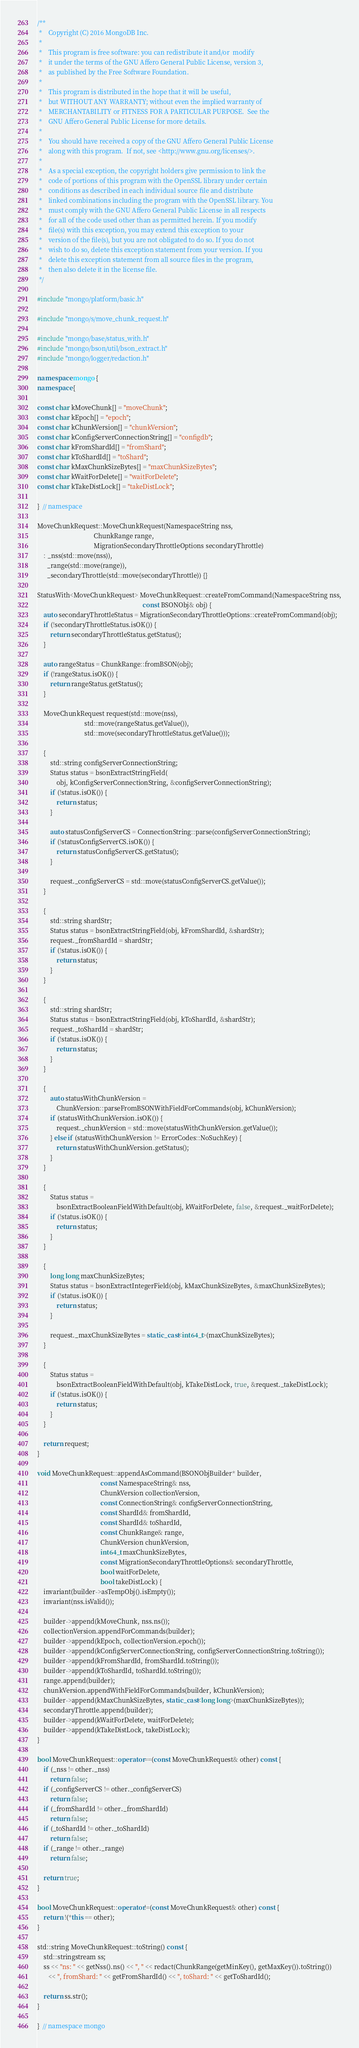<code> <loc_0><loc_0><loc_500><loc_500><_C++_>/**
 *    Copyright (C) 2016 MongoDB Inc.
 *
 *    This program is free software: you can redistribute it and/or  modify
 *    it under the terms of the GNU Affero General Public License, version 3,
 *    as published by the Free Software Foundation.
 *
 *    This program is distributed in the hope that it will be useful,
 *    but WITHOUT ANY WARRANTY; without even the implied warranty of
 *    MERCHANTABILITY or FITNESS FOR A PARTICULAR PURPOSE.  See the
 *    GNU Affero General Public License for more details.
 *
 *    You should have received a copy of the GNU Affero General Public License
 *    along with this program.  If not, see <http://www.gnu.org/licenses/>.
 *
 *    As a special exception, the copyright holders give permission to link the
 *    code of portions of this program with the OpenSSL library under certain
 *    conditions as described in each individual source file and distribute
 *    linked combinations including the program with the OpenSSL library. You
 *    must comply with the GNU Affero General Public License in all respects
 *    for all of the code used other than as permitted herein. If you modify
 *    file(s) with this exception, you may extend this exception to your
 *    version of the file(s), but you are not obligated to do so. If you do not
 *    wish to do so, delete this exception statement from your version. If you
 *    delete this exception statement from all source files in the program,
 *    then also delete it in the license file.
 */

#include "mongo/platform/basic.h"

#include "mongo/s/move_chunk_request.h"

#include "mongo/base/status_with.h"
#include "mongo/bson/util/bson_extract.h"
#include "mongo/logger/redaction.h"

namespace mongo {
namespace {

const char kMoveChunk[] = "moveChunk";
const char kEpoch[] = "epoch";
const char kChunkVersion[] = "chunkVersion";
const char kConfigServerConnectionString[] = "configdb";
const char kFromShardId[] = "fromShard";
const char kToShardId[] = "toShard";
const char kMaxChunkSizeBytes[] = "maxChunkSizeBytes";
const char kWaitForDelete[] = "waitForDelete";
const char kTakeDistLock[] = "takeDistLock";

}  // namespace

MoveChunkRequest::MoveChunkRequest(NamespaceString nss,
                                   ChunkRange range,
                                   MigrationSecondaryThrottleOptions secondaryThrottle)
    : _nss(std::move(nss)),
      _range(std::move(range)),
      _secondaryThrottle(std::move(secondaryThrottle)) {}

StatusWith<MoveChunkRequest> MoveChunkRequest::createFromCommand(NamespaceString nss,
                                                                 const BSONObj& obj) {
    auto secondaryThrottleStatus = MigrationSecondaryThrottleOptions::createFromCommand(obj);
    if (!secondaryThrottleStatus.isOK()) {
        return secondaryThrottleStatus.getStatus();
    }

    auto rangeStatus = ChunkRange::fromBSON(obj);
    if (!rangeStatus.isOK()) {
        return rangeStatus.getStatus();
    }

    MoveChunkRequest request(std::move(nss),
                             std::move(rangeStatus.getValue()),
                             std::move(secondaryThrottleStatus.getValue()));

    {
        std::string configServerConnectionString;
        Status status = bsonExtractStringField(
            obj, kConfigServerConnectionString, &configServerConnectionString);
        if (!status.isOK()) {
            return status;
        }

        auto statusConfigServerCS = ConnectionString::parse(configServerConnectionString);
        if (!statusConfigServerCS.isOK()) {
            return statusConfigServerCS.getStatus();
        }

        request._configServerCS = std::move(statusConfigServerCS.getValue());
    }

    {
        std::string shardStr;
        Status status = bsonExtractStringField(obj, kFromShardId, &shardStr);
        request._fromShardId = shardStr;
        if (!status.isOK()) {
            return status;
        }
    }

    {
        std::string shardStr;
        Status status = bsonExtractStringField(obj, kToShardId, &shardStr);
        request._toShardId = shardStr;
        if (!status.isOK()) {
            return status;
        }
    }

    {
        auto statusWithChunkVersion =
            ChunkVersion::parseFromBSONWithFieldForCommands(obj, kChunkVersion);
        if (statusWithChunkVersion.isOK()) {
            request._chunkVersion = std::move(statusWithChunkVersion.getValue());
        } else if (statusWithChunkVersion != ErrorCodes::NoSuchKey) {
            return statusWithChunkVersion.getStatus();
        }
    }

    {
        Status status =
            bsonExtractBooleanFieldWithDefault(obj, kWaitForDelete, false, &request._waitForDelete);
        if (!status.isOK()) {
            return status;
        }
    }

    {
        long long maxChunkSizeBytes;
        Status status = bsonExtractIntegerField(obj, kMaxChunkSizeBytes, &maxChunkSizeBytes);
        if (!status.isOK()) {
            return status;
        }

        request._maxChunkSizeBytes = static_cast<int64_t>(maxChunkSizeBytes);
    }

    {
        Status status =
            bsonExtractBooleanFieldWithDefault(obj, kTakeDistLock, true, &request._takeDistLock);
        if (!status.isOK()) {
            return status;
        }
    }

    return request;
}

void MoveChunkRequest::appendAsCommand(BSONObjBuilder* builder,
                                       const NamespaceString& nss,
                                       ChunkVersion collectionVersion,
                                       const ConnectionString& configServerConnectionString,
                                       const ShardId& fromShardId,
                                       const ShardId& toShardId,
                                       const ChunkRange& range,
                                       ChunkVersion chunkVersion,
                                       int64_t maxChunkSizeBytes,
                                       const MigrationSecondaryThrottleOptions& secondaryThrottle,
                                       bool waitForDelete,
                                       bool takeDistLock) {
    invariant(builder->asTempObj().isEmpty());
    invariant(nss.isValid());

    builder->append(kMoveChunk, nss.ns());
    collectionVersion.appendForCommands(builder);
    builder->append(kEpoch, collectionVersion.epoch());
    builder->append(kConfigServerConnectionString, configServerConnectionString.toString());
    builder->append(kFromShardId, fromShardId.toString());
    builder->append(kToShardId, toShardId.toString());
    range.append(builder);
    chunkVersion.appendWithFieldForCommands(builder, kChunkVersion);
    builder->append(kMaxChunkSizeBytes, static_cast<long long>(maxChunkSizeBytes));
    secondaryThrottle.append(builder);
    builder->append(kWaitForDelete, waitForDelete);
    builder->append(kTakeDistLock, takeDistLock);
}

bool MoveChunkRequest::operator==(const MoveChunkRequest& other) const {
    if (_nss != other._nss)
        return false;
    if (_configServerCS != other._configServerCS)
        return false;
    if (_fromShardId != other._fromShardId)
        return false;
    if (_toShardId != other._toShardId)
        return false;
    if (_range != other._range)
        return false;

    return true;
}

bool MoveChunkRequest::operator!=(const MoveChunkRequest& other) const {
    return !(*this == other);
}

std::string MoveChunkRequest::toString() const {
    std::stringstream ss;
    ss << "ns: " << getNss().ns() << ", " << redact(ChunkRange(getMinKey(), getMaxKey()).toString())
       << ", fromShard: " << getFromShardId() << ", toShard: " << getToShardId();

    return ss.str();
}

}  // namespace mongo
</code> 